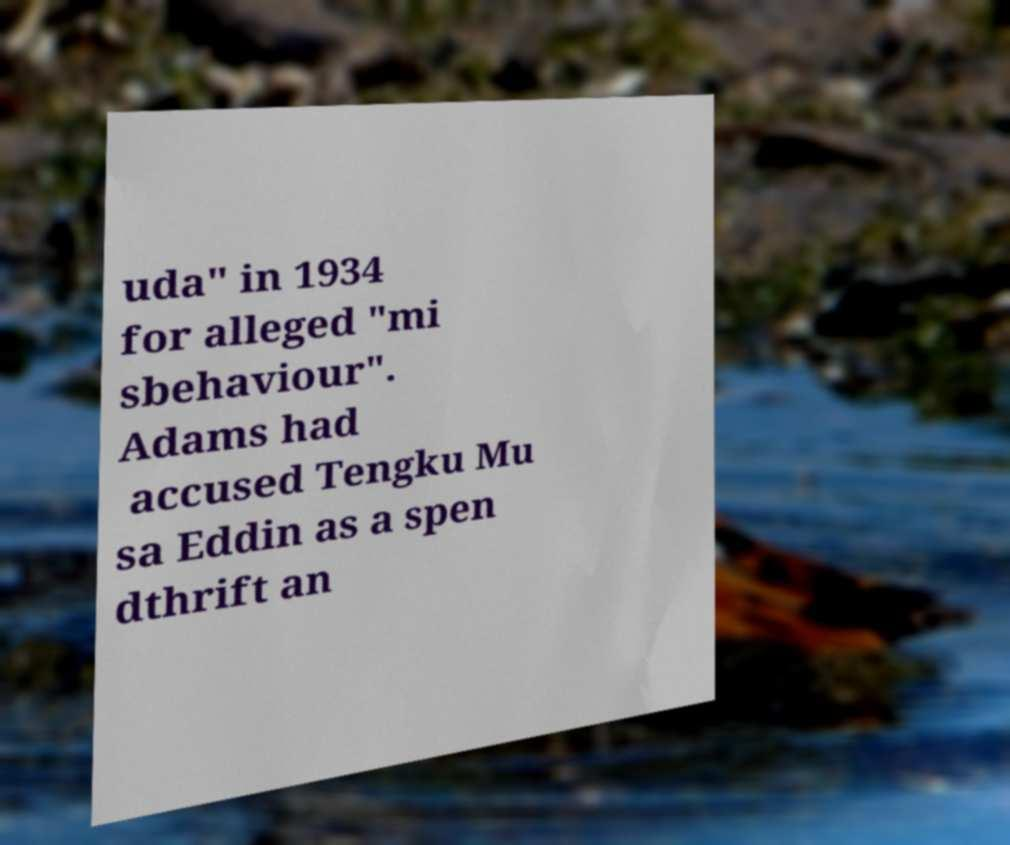Can you accurately transcribe the text from the provided image for me? uda" in 1934 for alleged "mi sbehaviour". Adams had accused Tengku Mu sa Eddin as a spen dthrift an 